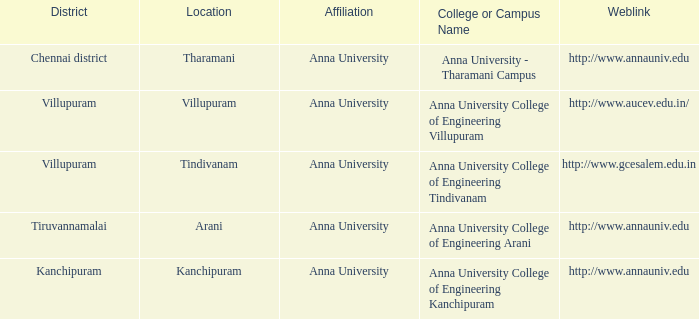Can you provide the web address for the college or campus named anna university college of engineering kanchipuram? Http://www.annauniv.edu. 